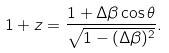<formula> <loc_0><loc_0><loc_500><loc_500>1 + z = \frac { 1 + \Delta \beta \cos \theta } { \sqrt { 1 - ( \Delta \beta ) ^ { 2 } } } .</formula> 